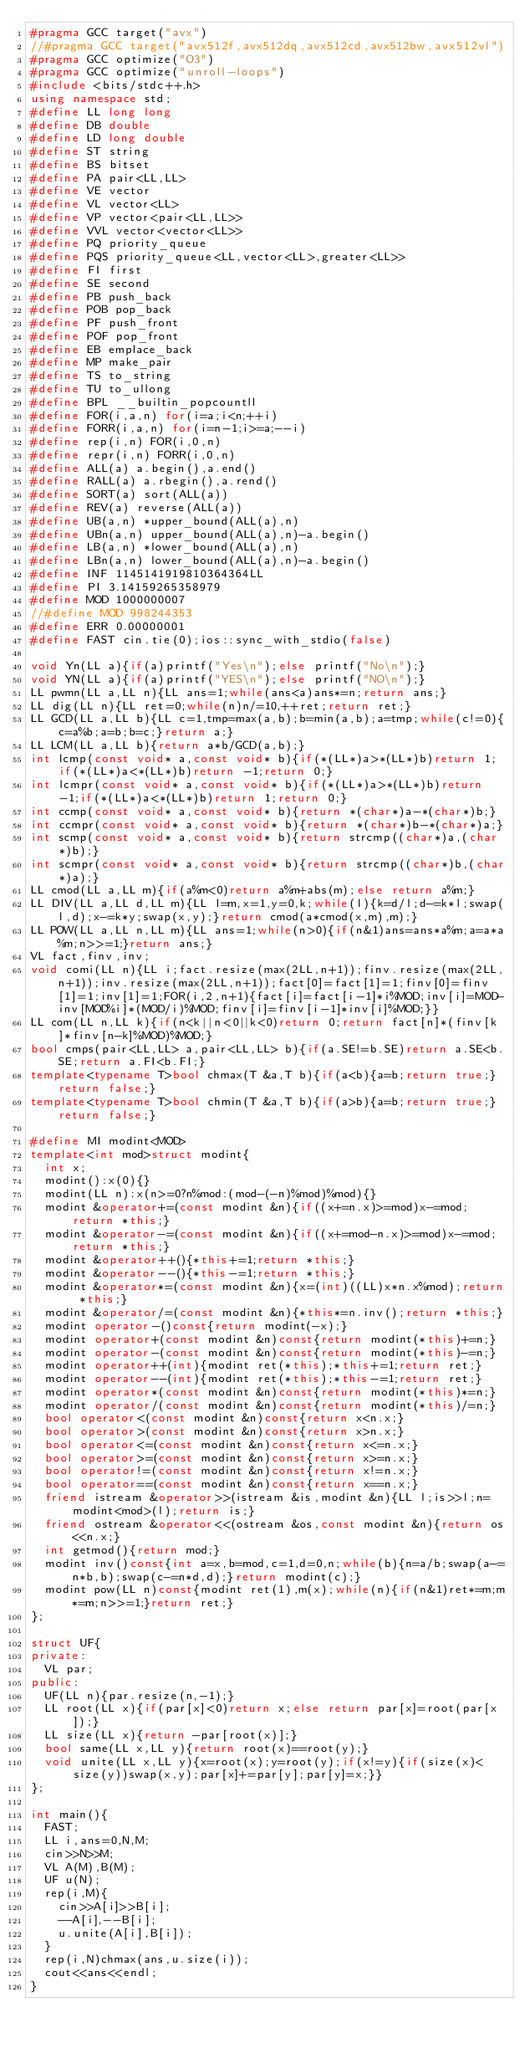<code> <loc_0><loc_0><loc_500><loc_500><_C++_>#pragma GCC target("avx")
//#pragma GCC target("avx512f,avx512dq,avx512cd,avx512bw,avx512vl")
#pragma GCC optimize("O3")
#pragma GCC optimize("unroll-loops")
#include <bits/stdc++.h>
using namespace std;
#define LL long long
#define DB double
#define LD long double
#define ST string
#define BS bitset
#define PA pair<LL,LL>
#define VE vector
#define VL vector<LL>
#define VP vector<pair<LL,LL>>
#define VVL vector<vector<LL>>
#define PQ priority_queue
#define PQS priority_queue<LL,vector<LL>,greater<LL>>
#define FI first
#define SE second
#define PB push_back
#define POB pop_back
#define PF push_front
#define POF pop_front
#define EB emplace_back
#define MP make_pair
#define TS to_string
#define TU to_ullong
#define BPL __builtin_popcountll
#define FOR(i,a,n) for(i=a;i<n;++i)
#define FORR(i,a,n) for(i=n-1;i>=a;--i)
#define rep(i,n) FOR(i,0,n)
#define repr(i,n) FORR(i,0,n)
#define ALL(a) a.begin(),a.end()
#define RALL(a) a.rbegin(),a.rend()
#define SORT(a) sort(ALL(a))
#define REV(a) reverse(ALL(a))
#define UB(a,n) *upper_bound(ALL(a),n)
#define UBn(a,n) upper_bound(ALL(a),n)-a.begin()
#define LB(a,n) *lower_bound(ALL(a),n)
#define LBn(a,n) lower_bound(ALL(a),n)-a.begin()
#define INF 1145141919810364364LL
#define PI 3.14159265358979
#define MOD 1000000007
//#define MOD 998244353
#define ERR 0.00000001
#define FAST cin.tie(0);ios::sync_with_stdio(false)

void Yn(LL a){if(a)printf("Yes\n");else printf("No\n");}
void YN(LL a){if(a)printf("YES\n");else printf("NO\n");}
LL pwmn(LL a,LL n){LL ans=1;while(ans<a)ans*=n;return ans;}
LL dig(LL n){LL ret=0;while(n)n/=10,++ret;return ret;}
LL GCD(LL a,LL b){LL c=1,tmp=max(a,b);b=min(a,b);a=tmp;while(c!=0){c=a%b;a=b;b=c;}return a;}
LL LCM(LL a,LL b){return a*b/GCD(a,b);}
int lcmp(const void* a,const void* b){if(*(LL*)a>*(LL*)b)return 1;if(*(LL*)a<*(LL*)b)return -1;return 0;}
int lcmpr(const void* a,const void* b){if(*(LL*)a>*(LL*)b)return -1;if(*(LL*)a<*(LL*)b)return 1;return 0;}
int ccmp(const void* a,const void* b){return *(char*)a-*(char*)b;}
int ccmpr(const void* a,const void* b){return *(char*)b-*(char*)a;}
int scmp(const void* a,const void* b){return strcmp((char*)a,(char*)b);}
int scmpr(const void* a,const void* b){return strcmp((char*)b,(char*)a);}
LL cmod(LL a,LL m){if(a%m<0)return a%m+abs(m);else return a%m;}
LL DIV(LL a,LL d,LL m){LL l=m,x=1,y=0,k;while(l){k=d/l;d-=k*l;swap(l,d);x-=k*y;swap(x,y);}return cmod(a*cmod(x,m),m);}
LL POW(LL a,LL n,LL m){LL ans=1;while(n>0){if(n&1)ans=ans*a%m;a=a*a%m;n>>=1;}return ans;}
VL fact,finv,inv;
void comi(LL n){LL i;fact.resize(max(2LL,n+1));finv.resize(max(2LL,n+1));inv.resize(max(2LL,n+1));fact[0]=fact[1]=1;finv[0]=finv[1]=1;inv[1]=1;FOR(i,2,n+1){fact[i]=fact[i-1]*i%MOD;inv[i]=MOD-inv[MOD%i]*(MOD/i)%MOD;finv[i]=finv[i-1]*inv[i]%MOD;}}
LL com(LL n,LL k){if(n<k||n<0||k<0)return 0;return fact[n]*(finv[k]*finv[n-k]%MOD)%MOD;}
bool cmps(pair<LL,LL> a,pair<LL,LL> b){if(a.SE!=b.SE)return a.SE<b.SE;return a.FI<b.FI;}
template<typename T>bool chmax(T &a,T b){if(a<b){a=b;return true;}return false;}
template<typename T>bool chmin(T &a,T b){if(a>b){a=b;return true;}return false;}

#define MI modint<MOD>
template<int mod>struct modint{
	int x;
	modint():x(0){}
	modint(LL n):x(n>=0?n%mod:(mod-(-n)%mod)%mod){}
	modint &operator+=(const modint &n){if((x+=n.x)>=mod)x-=mod;return *this;}
	modint &operator-=(const modint &n){if((x+=mod-n.x)>=mod)x-=mod;return *this;}
	modint &operator++(){*this+=1;return *this;}
  modint &operator--(){*this-=1;return *this;}
	modint &operator*=(const modint &n){x=(int)((LL)x*n.x%mod);return *this;}
	modint &operator/=(const modint &n){*this*=n.inv();return *this;}
	modint operator-()const{return modint(-x);}
	modint operator+(const modint &n)const{return modint(*this)+=n;}
	modint operator-(const modint &n)const{return modint(*this)-=n;}
	modint operator++(int){modint ret(*this);*this+=1;return ret;}
  modint operator--(int){modint ret(*this);*this-=1;return ret;}
	modint operator*(const modint &n)const{return modint(*this)*=n;}
	modint operator/(const modint &n)const{return modint(*this)/=n;}
	bool operator<(const modint &n)const{return x<n.x;}
	bool operator>(const modint &n)const{return x>n.x;}
	bool operator<=(const modint &n)const{return x<=n.x;}
	bool operator>=(const modint &n)const{return x>=n.x;}
	bool operator!=(const modint &n)const{return x!=n.x;}
	bool operator==(const modint &n)const{return x==n.x;}
	friend istream &operator>>(istream &is,modint &n){LL l;is>>l;n=modint<mod>(l);return is;}
	friend ostream &operator<<(ostream &os,const modint &n){return os<<n.x;}
	int getmod(){return mod;}
	modint inv()const{int a=x,b=mod,c=1,d=0,n;while(b){n=a/b;swap(a-=n*b,b);swap(c-=n*d,d);}return modint(c);}
	modint pow(LL n)const{modint ret(1),m(x);while(n){if(n&1)ret*=m;m*=m;n>>=1;}return ret;}
};

struct UF{
private:
  VL par;
public:
  UF(LL n){par.resize(n,-1);}
  LL root(LL x){if(par[x]<0)return x;else return par[x]=root(par[x]);}
  LL size(LL x){return -par[root(x)];}
  bool same(LL x,LL y){return root(x)==root(y);}
  void unite(LL x,LL y){x=root(x);y=root(y);if(x!=y){if(size(x)<size(y))swap(x,y);par[x]+=par[y];par[y]=x;}}
};

int main(){
  FAST;
  LL i,ans=0,N,M;
	cin>>N>>M;
	VL A(M),B(M);
	UF u(N);
	rep(i,M){
		cin>>A[i]>>B[i];
		--A[i],--B[i];
		u.unite(A[i],B[i]);
	}
	rep(i,N)chmax(ans,u.size(i));
	cout<<ans<<endl;
}
</code> 